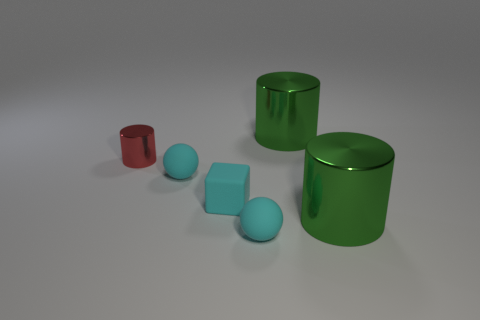Add 2 large green shiny cylinders. How many objects exist? 8 Subtract all balls. How many objects are left? 4 Add 1 small red cylinders. How many small red cylinders exist? 2 Subtract 0 purple balls. How many objects are left? 6 Subtract all green cylinders. Subtract all big metallic objects. How many objects are left? 2 Add 6 small red cylinders. How many small red cylinders are left? 7 